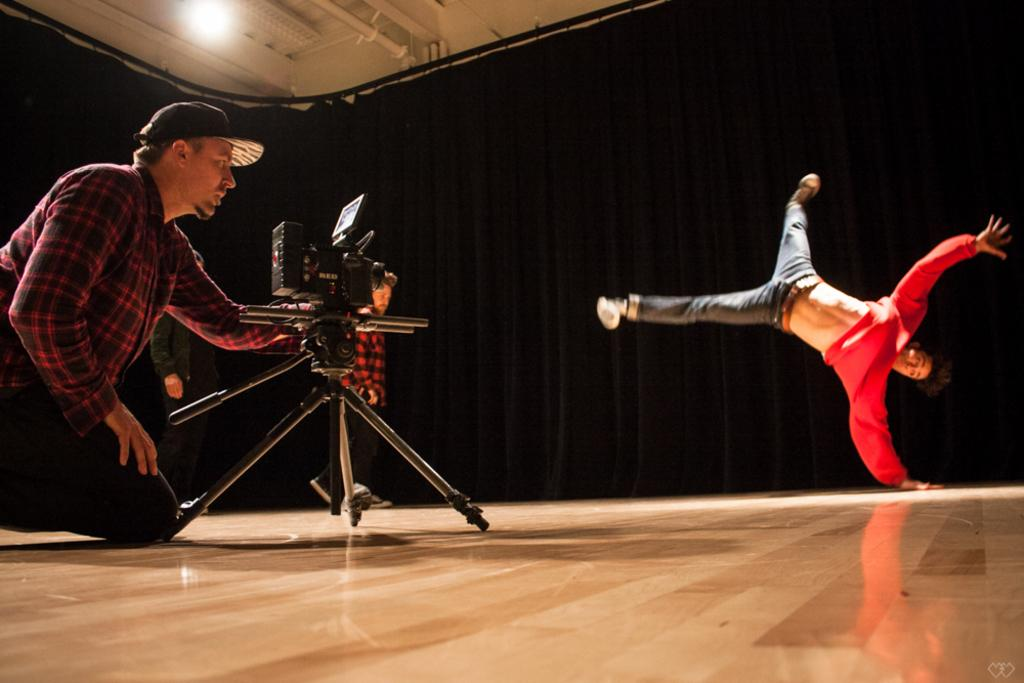How many people are present in the image? There are two people in the image. What can be seen hanging near the window in the image? There are curtains in the image. What is the source of light in the image? There is a light in the image. What device is used to capture the image? There is a camera in the image. What type of vessel is being used by the people in the image? There is no vessel present in the image; it features two people, curtains, a light, and a camera. 